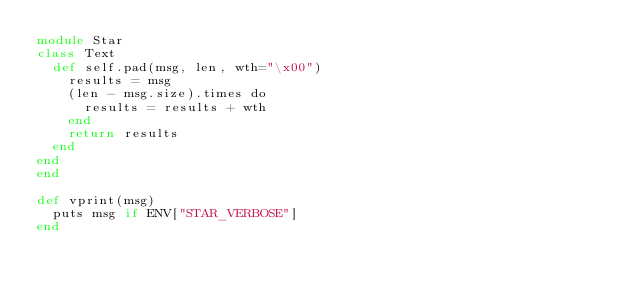<code> <loc_0><loc_0><loc_500><loc_500><_Crystal_>module Star
class Text
  def self.pad(msg, len, wth="\x00")
    results = msg
    (len - msg.size).times do
      results = results + wth
    end
    return results
  end
end
end

def vprint(msg)
  puts msg if ENV["STAR_VERBOSE"]
end</code> 